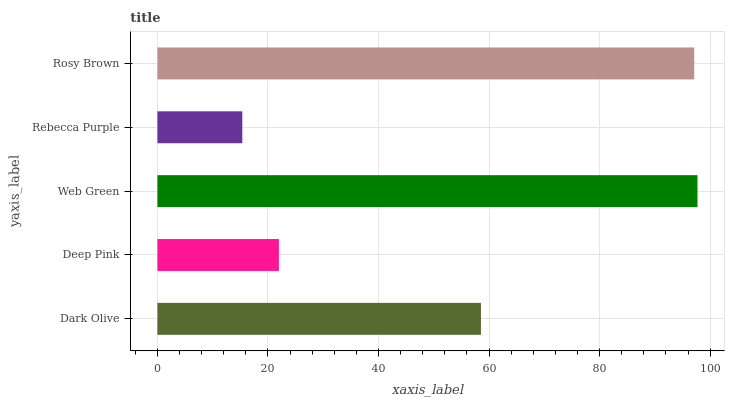Is Rebecca Purple the minimum?
Answer yes or no. Yes. Is Web Green the maximum?
Answer yes or no. Yes. Is Deep Pink the minimum?
Answer yes or no. No. Is Deep Pink the maximum?
Answer yes or no. No. Is Dark Olive greater than Deep Pink?
Answer yes or no. Yes. Is Deep Pink less than Dark Olive?
Answer yes or no. Yes. Is Deep Pink greater than Dark Olive?
Answer yes or no. No. Is Dark Olive less than Deep Pink?
Answer yes or no. No. Is Dark Olive the high median?
Answer yes or no. Yes. Is Dark Olive the low median?
Answer yes or no. Yes. Is Web Green the high median?
Answer yes or no. No. Is Web Green the low median?
Answer yes or no. No. 